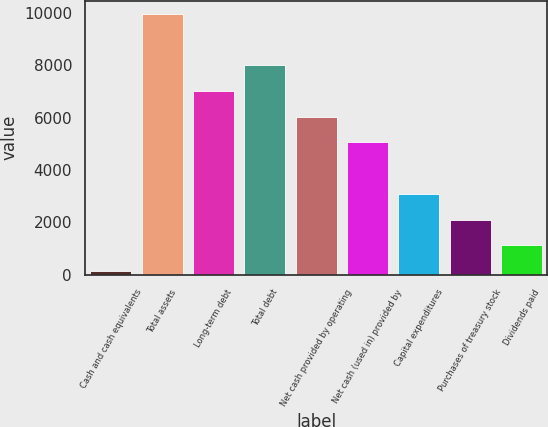Convert chart to OTSL. <chart><loc_0><loc_0><loc_500><loc_500><bar_chart><fcel>Cash and cash equivalents<fcel>Total assets<fcel>Long-term debt<fcel>Total debt<fcel>Net cash provided by operating<fcel>Net cash (used in) provided by<fcel>Capital expenditures<fcel>Purchases of treasury stock<fcel>Dividends paid<nl><fcel>133<fcel>9962<fcel>7013.3<fcel>7996.2<fcel>6030.4<fcel>5047.5<fcel>3081.7<fcel>2098.8<fcel>1115.9<nl></chart> 